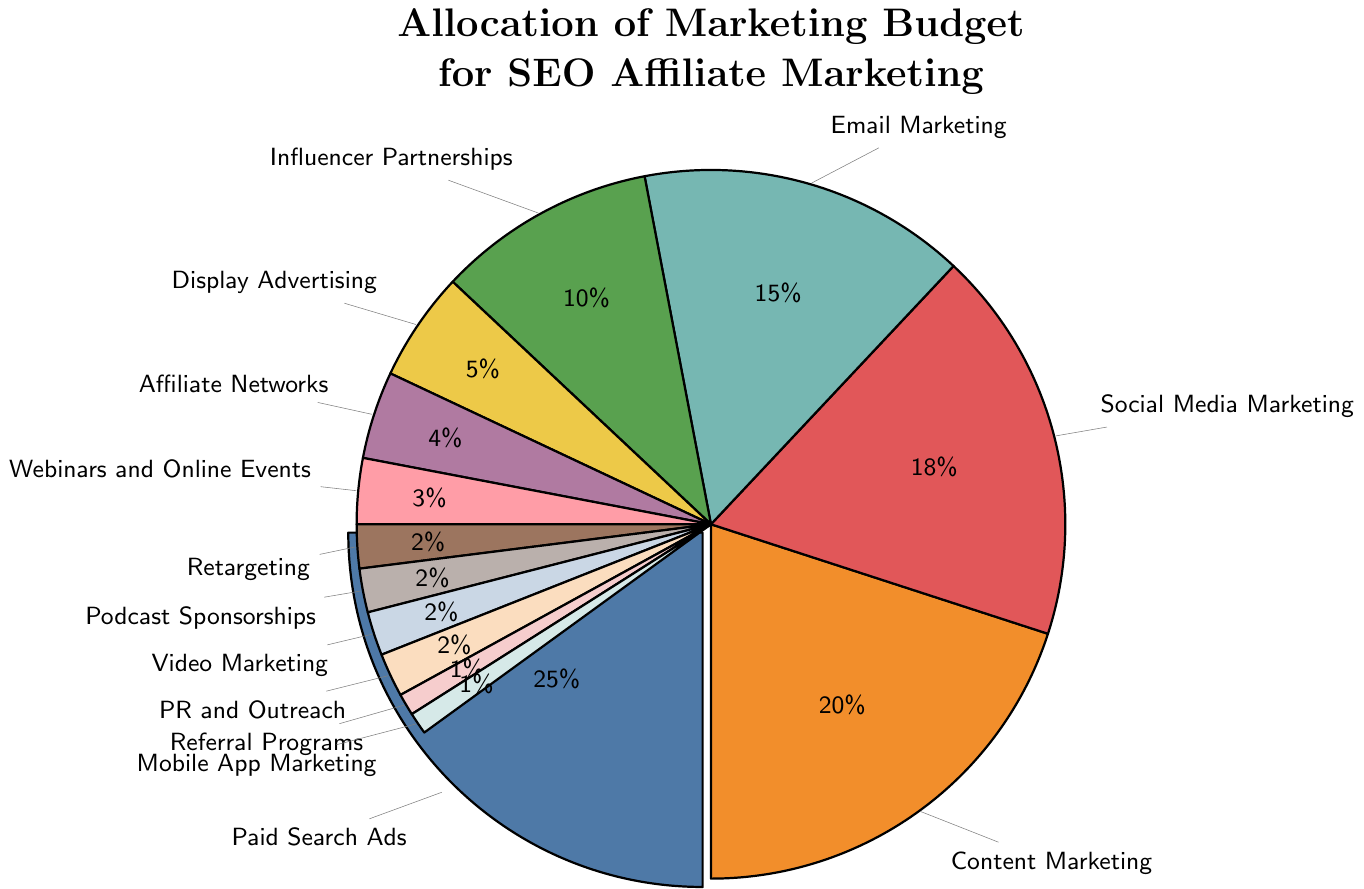What percentage of the marketing budget is allocated to social media marketing? Look at the segment labeled "Social Media Marketing" and note the percentage value indicated.
Answer: 18% Which channel receives the highest percentage of the marketing budget? Identify the largest segment in the pie chart. The largest segment is the one labeled "Paid Search Ads," which has the highest percentage value.
Answer: Paid Search Ads How much more budget is allocated to email marketing compared to display advertising? Find the percentages for email marketing (15%) and display advertising (5%). Subtract the smaller percentage from the larger one: 15% - 5%.
Answer: 10% What is the combined budget allocation for influencer partnerships, affiliate networks, and webinars and online events? Add the percentages for influencer partnerships (10%), affiliate networks (4%), and webinars and online events (3%). The sum is 10% + 4% + 3%.
Answer: 17% Which channels each have an allocation of 2%? Look at the segments labeled with a 2% allocation. These are retargeting, podcast sponsorships, video marketing, and PR and outreach.
Answer: Retargeting, Podcast Sponsorships, Video Marketing, PR and Outreach Is the budget for content marketing greater than the combined budget for social media marketing and email marketing? Calculate the combined budget for social media marketing and email marketing: 18% + 15% = 33%. Compare this with the budget for content marketing (20%).
Answer: No How much is the total budget allocated to channels with less than 5% allocation each? Add the percentages for all channels with less than 5% allocation: affiliate networks (4%), webinars and online events (3%), retargeting (2%), podcast sponsorships (2%), video marketing (2%), PR and outreach (2%), referral programs (1%), mobile app marketing (1%). The sum is 4% + 3% + 2% + 2% + 2% + 2% + 1% + 1%.
Answer: 17% What portion of the marketing budget is allocated to non-digital marketing channels? Analyze the channels and their percentage values. Assume digital channels include paid search ads, content marketing, social media marketing, email marketing, display advertising, retargeting, video marketing, mobile app marketing. Non-digital channels include influencer partnerships, affiliate networks, webinars and online events, podcast sponsorships, PR and outreach, referral programs. Add the percentages for the non-digital channels: 10% + 4% + 3% + 2% + 2% + 1%.
Answer: 22% What proportion of the budget is dedicated to customer interaction channels (such as social media marketing, email marketing, webinars, and online events)? Add the percentages for social media marketing (18%), email marketing (15%), and webinars and online events (3%). The sum is 18% + 15% + 3%.
Answer: 36% 